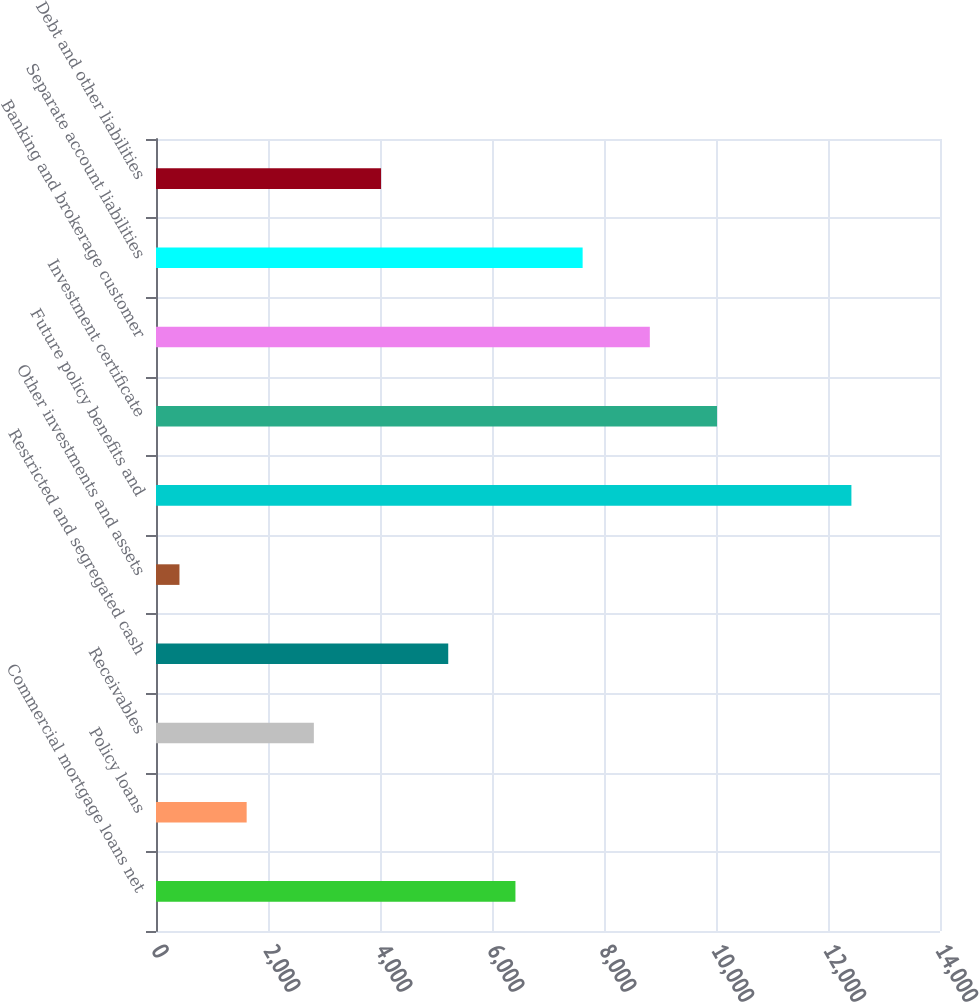Convert chart. <chart><loc_0><loc_0><loc_500><loc_500><bar_chart><fcel>Commercial mortgage loans net<fcel>Policy loans<fcel>Receivables<fcel>Restricted and segregated cash<fcel>Other investments and assets<fcel>Future policy benefits and<fcel>Investment certificate<fcel>Banking and brokerage customer<fcel>Separate account liabilities<fcel>Debt and other liabilities<nl><fcel>6418.5<fcel>1618.9<fcel>2818.8<fcel>5218.6<fcel>419<fcel>12418<fcel>10018.2<fcel>8818.3<fcel>7618.4<fcel>4018.7<nl></chart> 